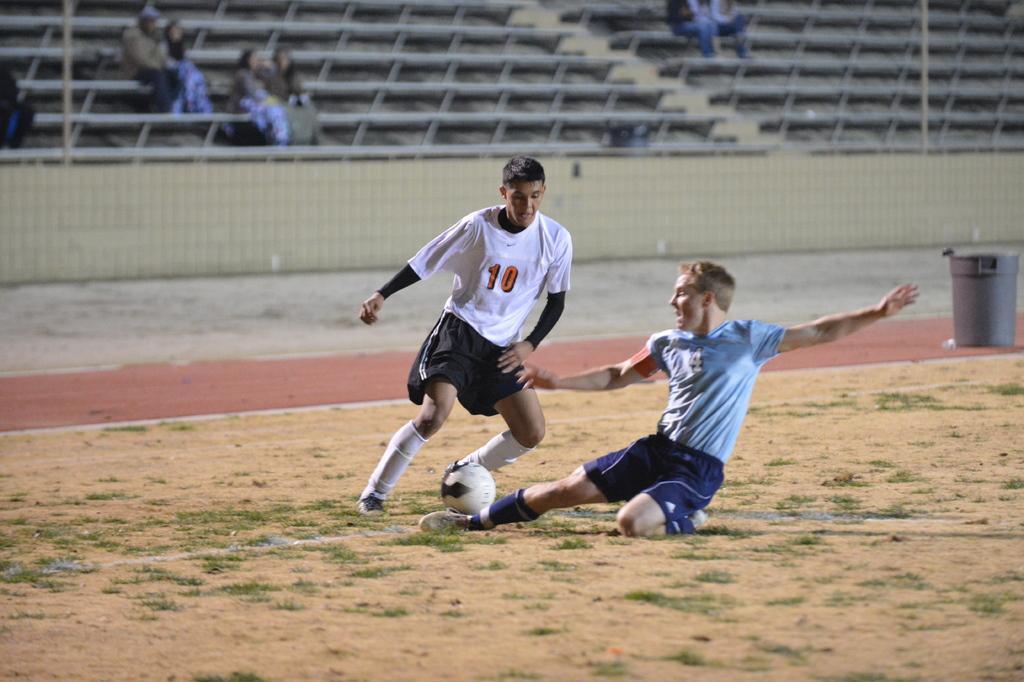Can you describe this image briefly? As we can see in the image there is a stadium and two people playing with football. 